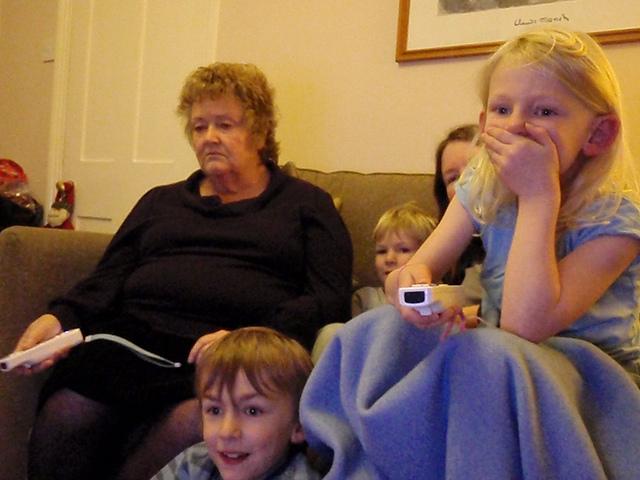Does the woman look excited about what she's doing?
Answer briefly. No. Where is the girl's hair tucked?
Concise answer only. Behind ears. Is the woman crying?
Concise answer only. No. 